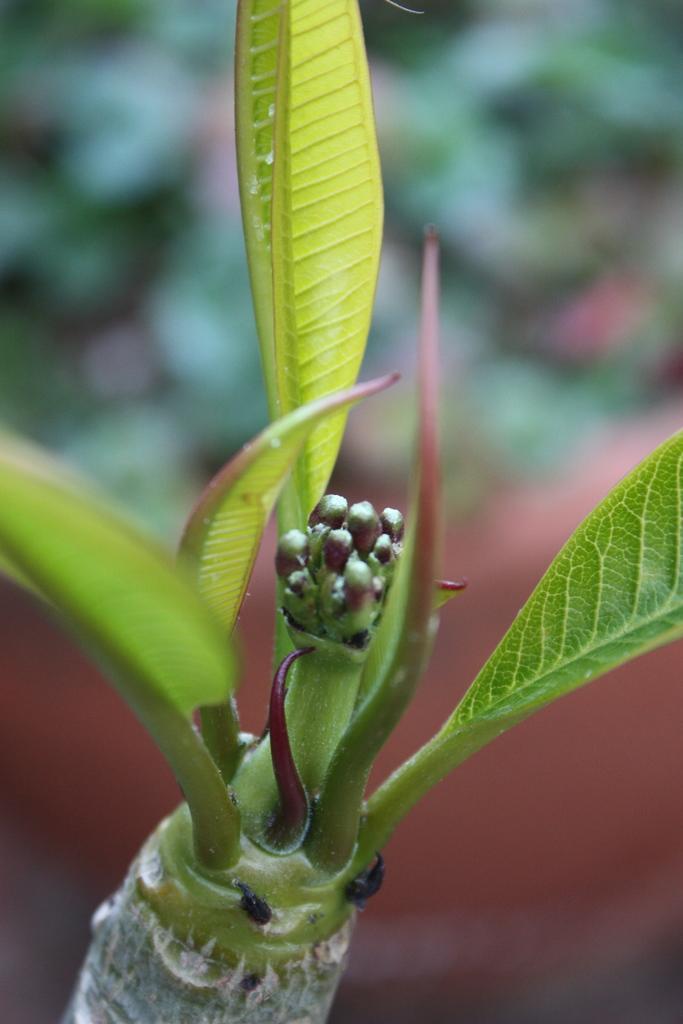How would you summarize this image in a sentence or two? In this image there is a plant, there is a flowerpot, the background of the image is blurred. 